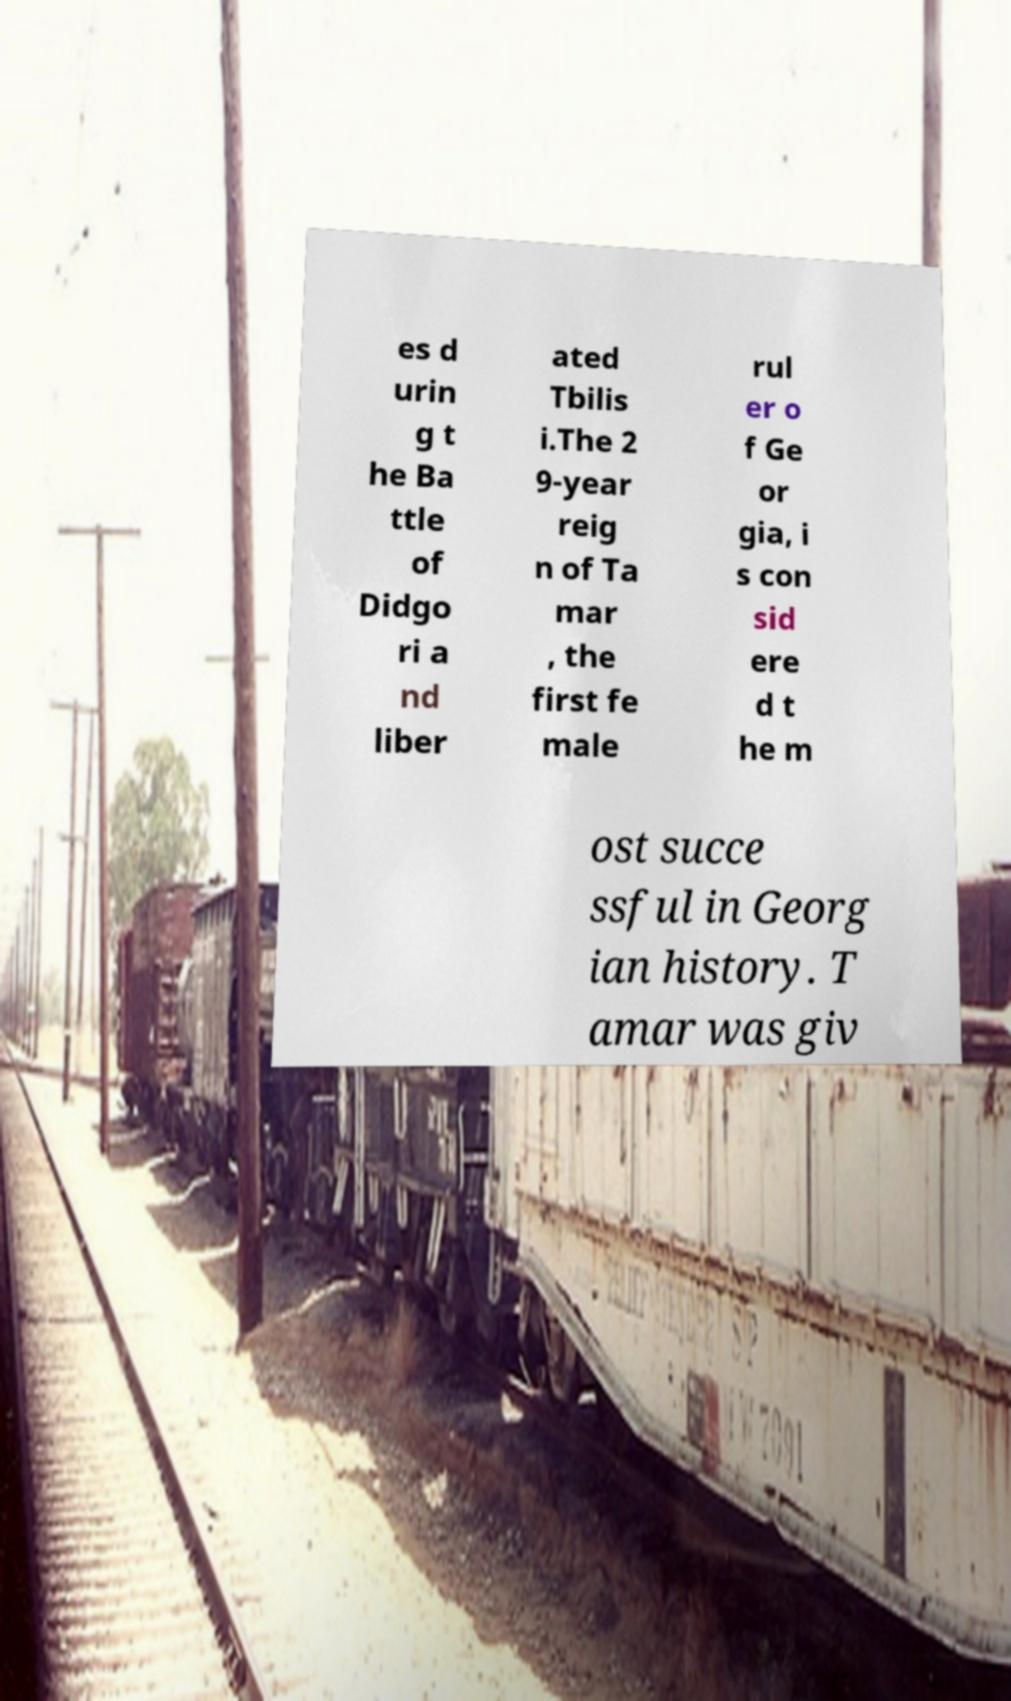Please identify and transcribe the text found in this image. es d urin g t he Ba ttle of Didgo ri a nd liber ated Tbilis i.The 2 9-year reig n of Ta mar , the first fe male rul er o f Ge or gia, i s con sid ere d t he m ost succe ssful in Georg ian history. T amar was giv 